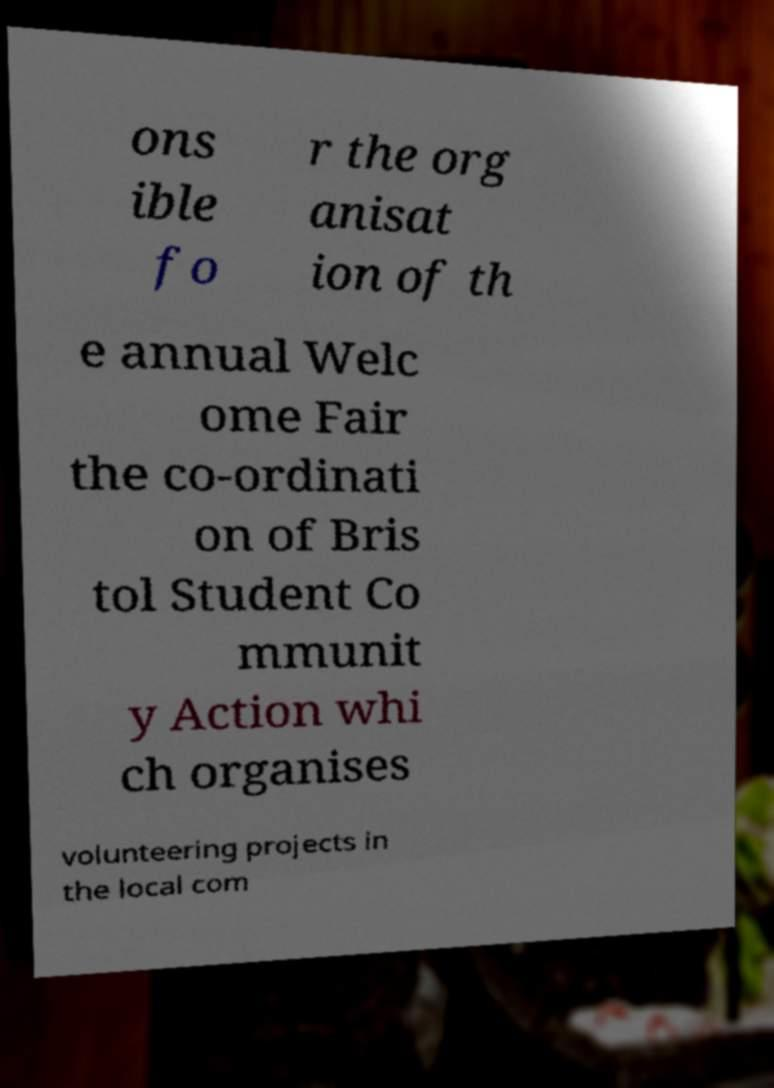Could you assist in decoding the text presented in this image and type it out clearly? ons ible fo r the org anisat ion of th e annual Welc ome Fair the co-ordinati on of Bris tol Student Co mmunit y Action whi ch organises volunteering projects in the local com 